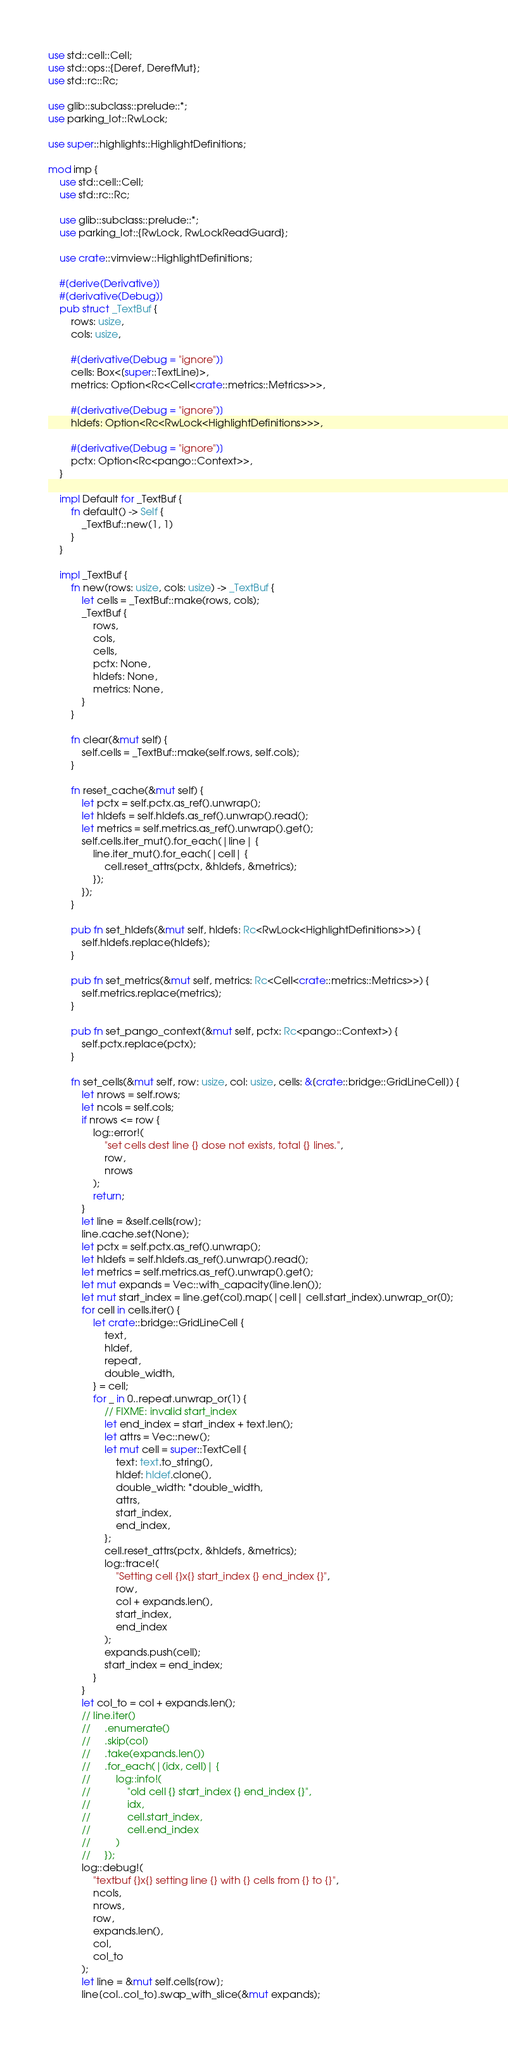<code> <loc_0><loc_0><loc_500><loc_500><_Rust_>use std::cell::Cell;
use std::ops::{Deref, DerefMut};
use std::rc::Rc;

use glib::subclass::prelude::*;
use parking_lot::RwLock;

use super::highlights::HighlightDefinitions;

mod imp {
    use std::cell::Cell;
    use std::rc::Rc;

    use glib::subclass::prelude::*;
    use parking_lot::{RwLock, RwLockReadGuard};

    use crate::vimview::HighlightDefinitions;

    #[derive(Derivative)]
    #[derivative(Debug)]
    pub struct _TextBuf {
        rows: usize,
        cols: usize,

        #[derivative(Debug = "ignore")]
        cells: Box<[super::TextLine]>,
        metrics: Option<Rc<Cell<crate::metrics::Metrics>>>,

        #[derivative(Debug = "ignore")]
        hldefs: Option<Rc<RwLock<HighlightDefinitions>>>,

        #[derivative(Debug = "ignore")]
        pctx: Option<Rc<pango::Context>>,
    }

    impl Default for _TextBuf {
        fn default() -> Self {
            _TextBuf::new(1, 1)
        }
    }

    impl _TextBuf {
        fn new(rows: usize, cols: usize) -> _TextBuf {
            let cells = _TextBuf::make(rows, cols);
            _TextBuf {
                rows,
                cols,
                cells,
                pctx: None,
                hldefs: None,
                metrics: None,
            }
        }

        fn clear(&mut self) {
            self.cells = _TextBuf::make(self.rows, self.cols);
        }

        fn reset_cache(&mut self) {
            let pctx = self.pctx.as_ref().unwrap();
            let hldefs = self.hldefs.as_ref().unwrap().read();
            let metrics = self.metrics.as_ref().unwrap().get();
            self.cells.iter_mut().for_each(|line| {
                line.iter_mut().for_each(|cell| {
                    cell.reset_attrs(pctx, &hldefs, &metrics);
                });
            });
        }

        pub fn set_hldefs(&mut self, hldefs: Rc<RwLock<HighlightDefinitions>>) {
            self.hldefs.replace(hldefs);
        }

        pub fn set_metrics(&mut self, metrics: Rc<Cell<crate::metrics::Metrics>>) {
            self.metrics.replace(metrics);
        }

        pub fn set_pango_context(&mut self, pctx: Rc<pango::Context>) {
            self.pctx.replace(pctx);
        }

        fn set_cells(&mut self, row: usize, col: usize, cells: &[crate::bridge::GridLineCell]) {
            let nrows = self.rows;
            let ncols = self.cols;
            if nrows <= row {
                log::error!(
                    "set cells dest line {} dose not exists, total {} lines.",
                    row,
                    nrows
                );
                return;
            }
            let line = &self.cells[row];
            line.cache.set(None);
            let pctx = self.pctx.as_ref().unwrap();
            let hldefs = self.hldefs.as_ref().unwrap().read();
            let metrics = self.metrics.as_ref().unwrap().get();
            let mut expands = Vec::with_capacity(line.len());
            let mut start_index = line.get(col).map(|cell| cell.start_index).unwrap_or(0);
            for cell in cells.iter() {
                let crate::bridge::GridLineCell {
                    text,
                    hldef,
                    repeat,
                    double_width,
                } = cell;
                for _ in 0..repeat.unwrap_or(1) {
                    // FIXME: invalid start_index
                    let end_index = start_index + text.len();
                    let attrs = Vec::new();
                    let mut cell = super::TextCell {
                        text: text.to_string(),
                        hldef: hldef.clone(),
                        double_width: *double_width,
                        attrs,
                        start_index,
                        end_index,
                    };
                    cell.reset_attrs(pctx, &hldefs, &metrics);
                    log::trace!(
                        "Setting cell {}x{} start_index {} end_index {}",
                        row,
                        col + expands.len(),
                        start_index,
                        end_index
                    );
                    expands.push(cell);
                    start_index = end_index;
                }
            }
            let col_to = col + expands.len();
            // line.iter()
            //     .enumerate()
            //     .skip(col)
            //     .take(expands.len())
            //     .for_each(|(idx, cell)| {
            //         log::info!(
            //             "old cell {} start_index {} end_index {}",
            //             idx,
            //             cell.start_index,
            //             cell.end_index
            //         )
            //     });
            log::debug!(
                "textbuf {}x{} setting line {} with {} cells from {} to {}",
                ncols,
                nrows,
                row,
                expands.len(),
                col,
                col_to
            );
            let line = &mut self.cells[row];
            line[col..col_to].swap_with_slice(&mut expands);</code> 